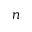Convert formula to latex. <formula><loc_0><loc_0><loc_500><loc_500>n</formula> 